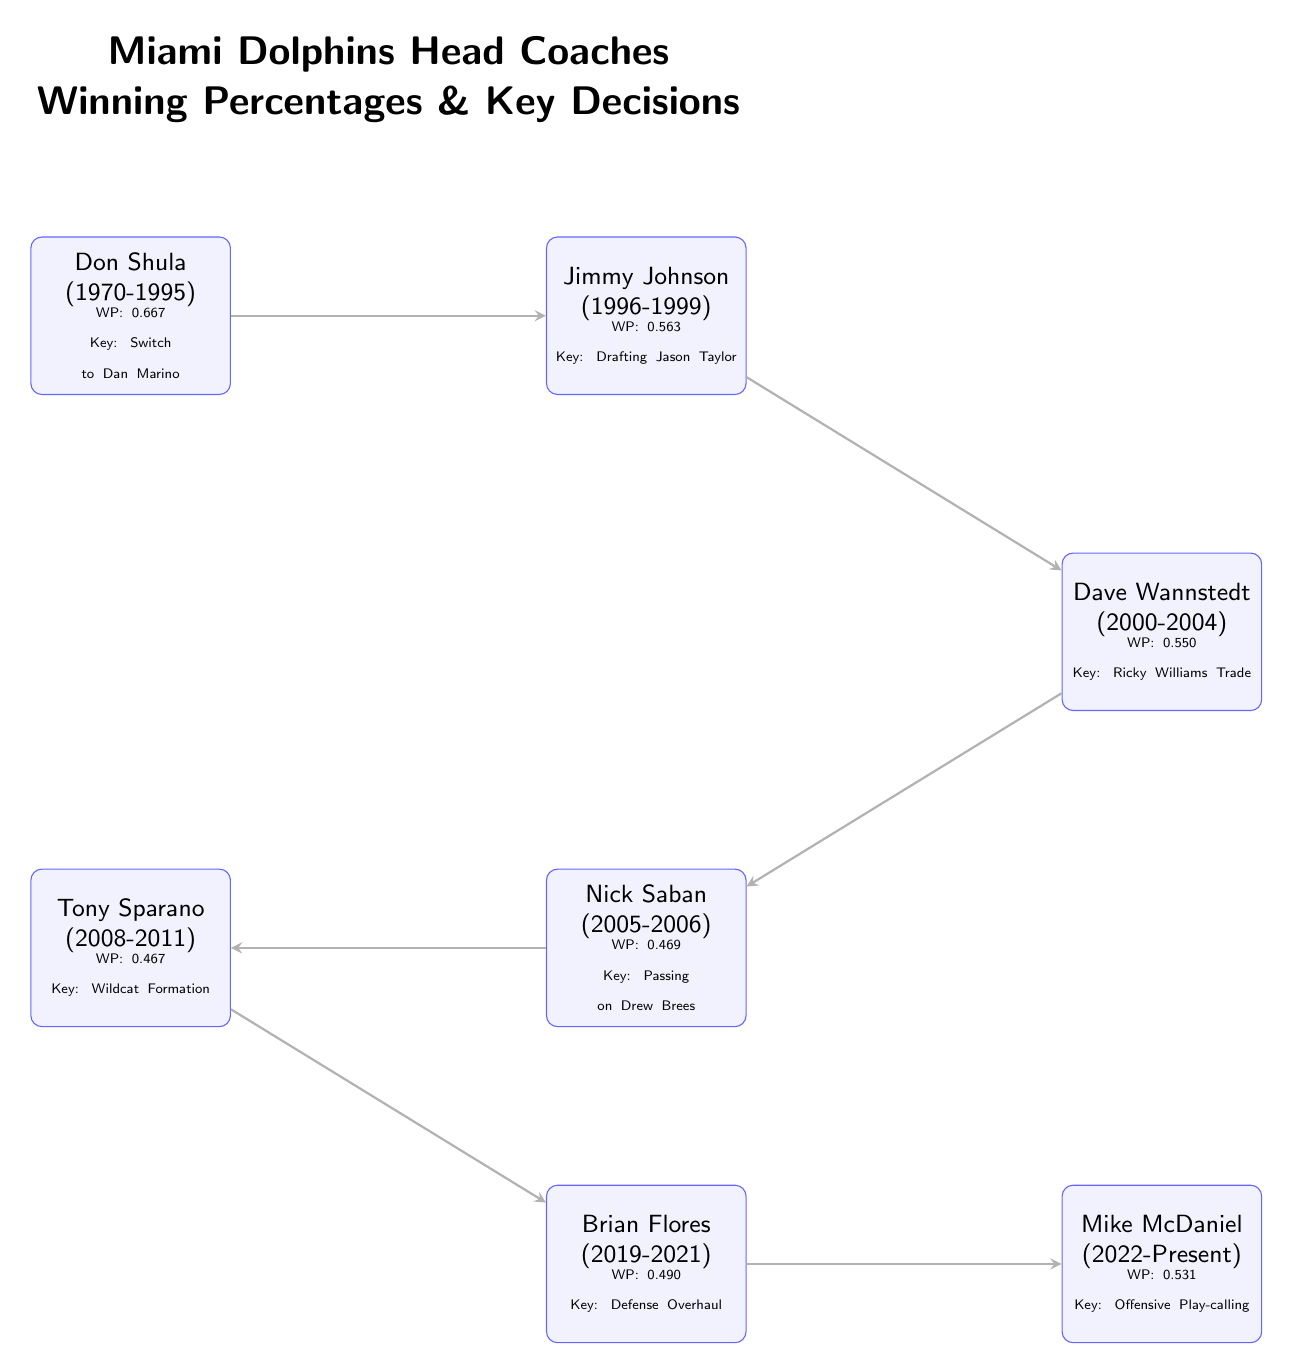What is the winning percentage of Don Shula? The diagram explicitly states that Don Shula has a winning percentage of 0.667.
Answer: 0.667 Who is located directly below Dave Wannstedt? According to the diagram, Nick Saban is positioned directly below Dave Wannstedt.
Answer: Nick Saban What key decision is associated with Mike McDaniel? The diagram highlights that Mike McDaniel's key decision is related to Offensive Play-calling.
Answer: Offensive Play-calling How many head coaches are represented in the diagram? By counting the coach nodes, the diagram shows a total of 6 head coaches are represented.
Answer: 6 What is the relationship between Jimmy Johnson and Dave Wannstedt? The diagram indicates a direct connection (arrow) from Jimmy Johnson to Dave Wannstedt, showing he succeeded him.
Answer: Succeeded Compare the winning percentage of Brian Flores and Tony Sparano. The diagram lists Brian Flores with a winning percentage of 0.490, which is higher than Tony Sparano's winning percentage of 0.467. This indicates a comparison where one coach outperforms the other.
Answer: 0.490 vs 0.467 What key decision did Nick Saban make that impacted his winning percentage? The diagram specifies that Nick Saban's key decision, which may have negatively impacted his winning percentage, was passing on Drew Brees.
Answer: Passing on Drew Brees Which head coach has the lowest winning percentage? The diagram shows that Tony Sparano has the lowest winning percentage at 0.467.
Answer: Tony Sparano What is the common focus across all head coaches in terms of decision-making? The diagram illustrates that each coach has been associated with a key strategic decision, indicating an emphasis on specific strategies that influenced team performance.
Answer: Strategic decisions Which coach’s tenure led to a notable defensive overhaul? The diagram indicates that the notable defensive overhaul was associated with Brian Flores during his coaching tenure.
Answer: Brian Flores 